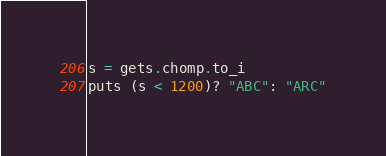Convert code to text. <code><loc_0><loc_0><loc_500><loc_500><_Ruby_>s = gets.chomp.to_i
puts (s < 1200)? "ABC": "ARC"</code> 